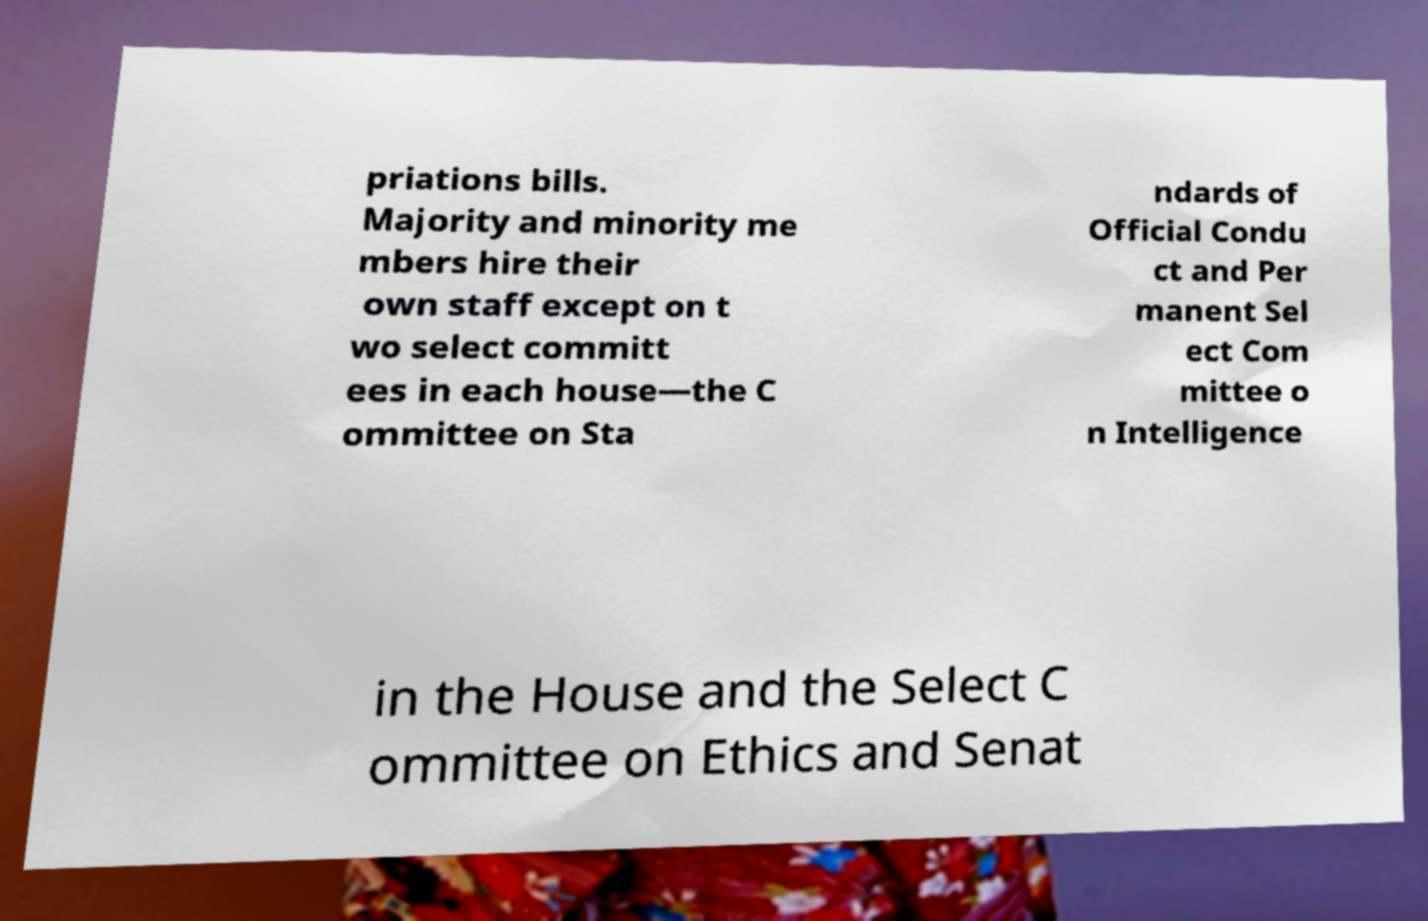I need the written content from this picture converted into text. Can you do that? priations bills. Majority and minority me mbers hire their own staff except on t wo select committ ees in each house—the C ommittee on Sta ndards of Official Condu ct and Per manent Sel ect Com mittee o n Intelligence in the House and the Select C ommittee on Ethics and Senat 